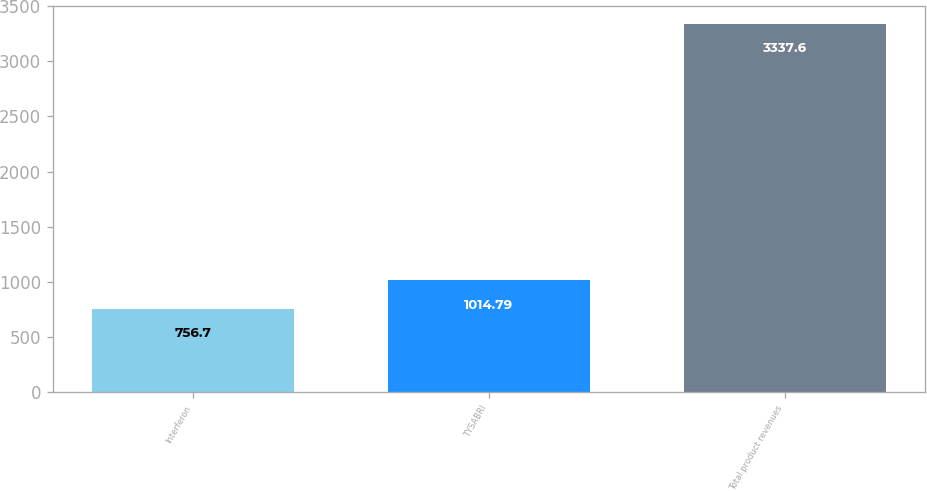Convert chart. <chart><loc_0><loc_0><loc_500><loc_500><bar_chart><fcel>Interferon<fcel>TYSABRI<fcel>Total product revenues<nl><fcel>756.7<fcel>1014.79<fcel>3337.6<nl></chart> 